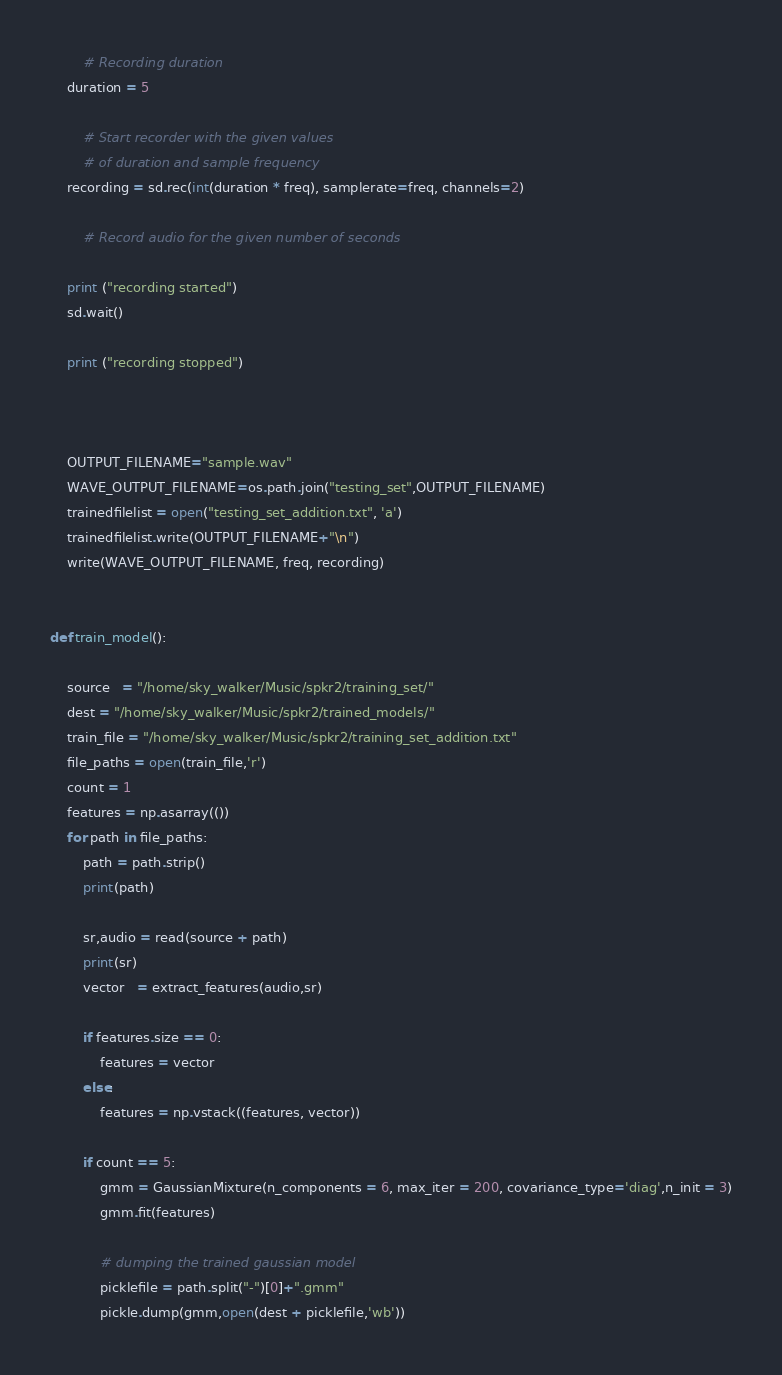Convert code to text. <code><loc_0><loc_0><loc_500><loc_500><_Python_>		# Recording duration
	duration = 5
  
		# Start recorder with the given values 
		# of duration and sample frequency
	recording = sd.rec(int(duration * freq), samplerate=freq, channels=2)
  
		# Record audio for the given number of seconds
		
	print ("recording started")
	sd.wait()
		
	print ("recording stopped")

	
	
	OUTPUT_FILENAME="sample.wav"
	WAVE_OUTPUT_FILENAME=os.path.join("testing_set",OUTPUT_FILENAME)
	trainedfilelist = open("testing_set_addition.txt", 'a')
	trainedfilelist.write(OUTPUT_FILENAME+"\n")
	write(WAVE_OUTPUT_FILENAME, freq, recording)
	

def train_model():

	source   = "/home/sky_walker/Music/spkr2/training_set/"   
	dest = "/home/sky_walker/Music/spkr2/trained_models/"
	train_file = "/home/sky_walker/Music/spkr2/training_set_addition.txt"        
	file_paths = open(train_file,'r')
	count = 1
	features = np.asarray(())
	for path in file_paths:    
	    path = path.strip()   
	    print(path)

	    sr,audio = read(source + path)
	    print(sr)
	    vector   = extract_features(audio,sr)
	    
	    if features.size == 0:
	        features = vector
	    else:
	        features = np.vstack((features, vector))

	    if count == 5:    
	        gmm = GaussianMixture(n_components = 6, max_iter = 200, covariance_type='diag',n_init = 3)
	        gmm.fit(features)
	        
	        # dumping the trained gaussian model
	        picklefile = path.split("-")[0]+".gmm"
	        pickle.dump(gmm,open(dest + picklefile,'wb'))</code> 